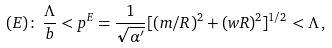Convert formula to latex. <formula><loc_0><loc_0><loc_500><loc_500>( E ) \colon \, \frac { \Lambda } { b } < p ^ { E } = \frac { 1 } { \sqrt { \alpha ^ { \prime } } } [ ( m / R ) ^ { 2 } + ( w R ) ^ { 2 } ] ^ { 1 / 2 } < \Lambda \, ,</formula> 